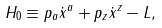<formula> <loc_0><loc_0><loc_500><loc_500>H _ { 0 } \equiv p _ { a } \dot { x } ^ { a } + p _ { z } \dot { x } ^ { z } - L ,</formula> 